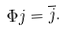Convert formula to latex. <formula><loc_0><loc_0><loc_500><loc_500>\Phi j = \overline { j } .</formula> 